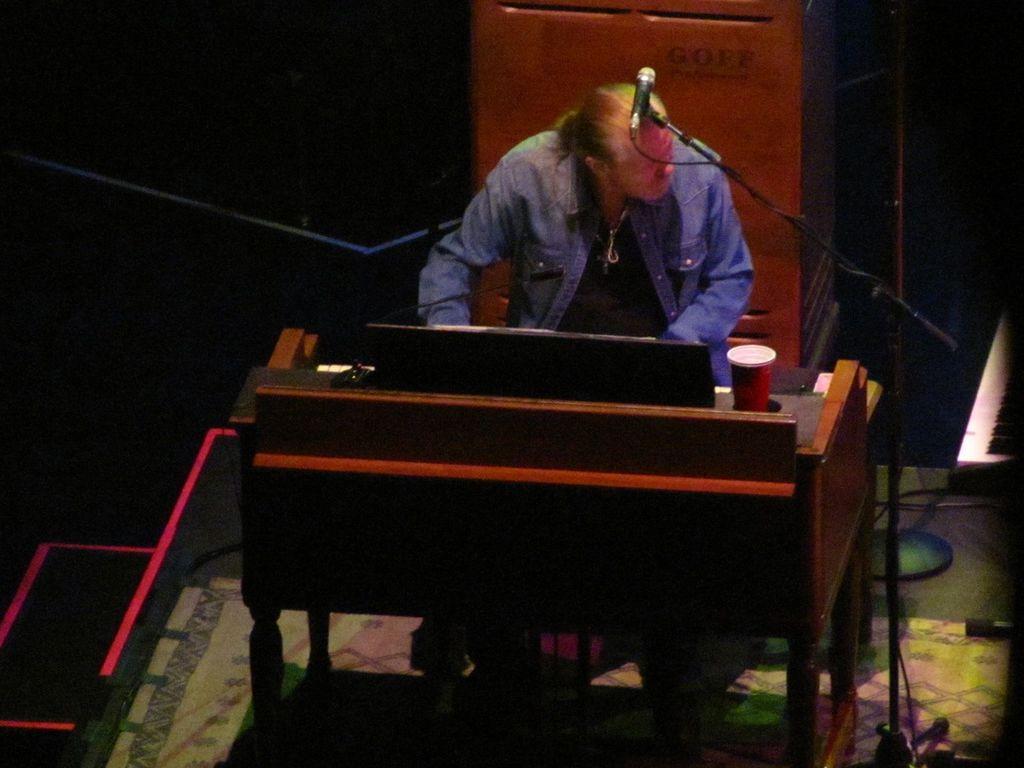Can you describe this image briefly? This picture is clicked inside a room. Here, we see a man wearing blue jacket is playing piano. On the table, we can see a glass and beside him, we see microphone. Behind him, we see podium. 